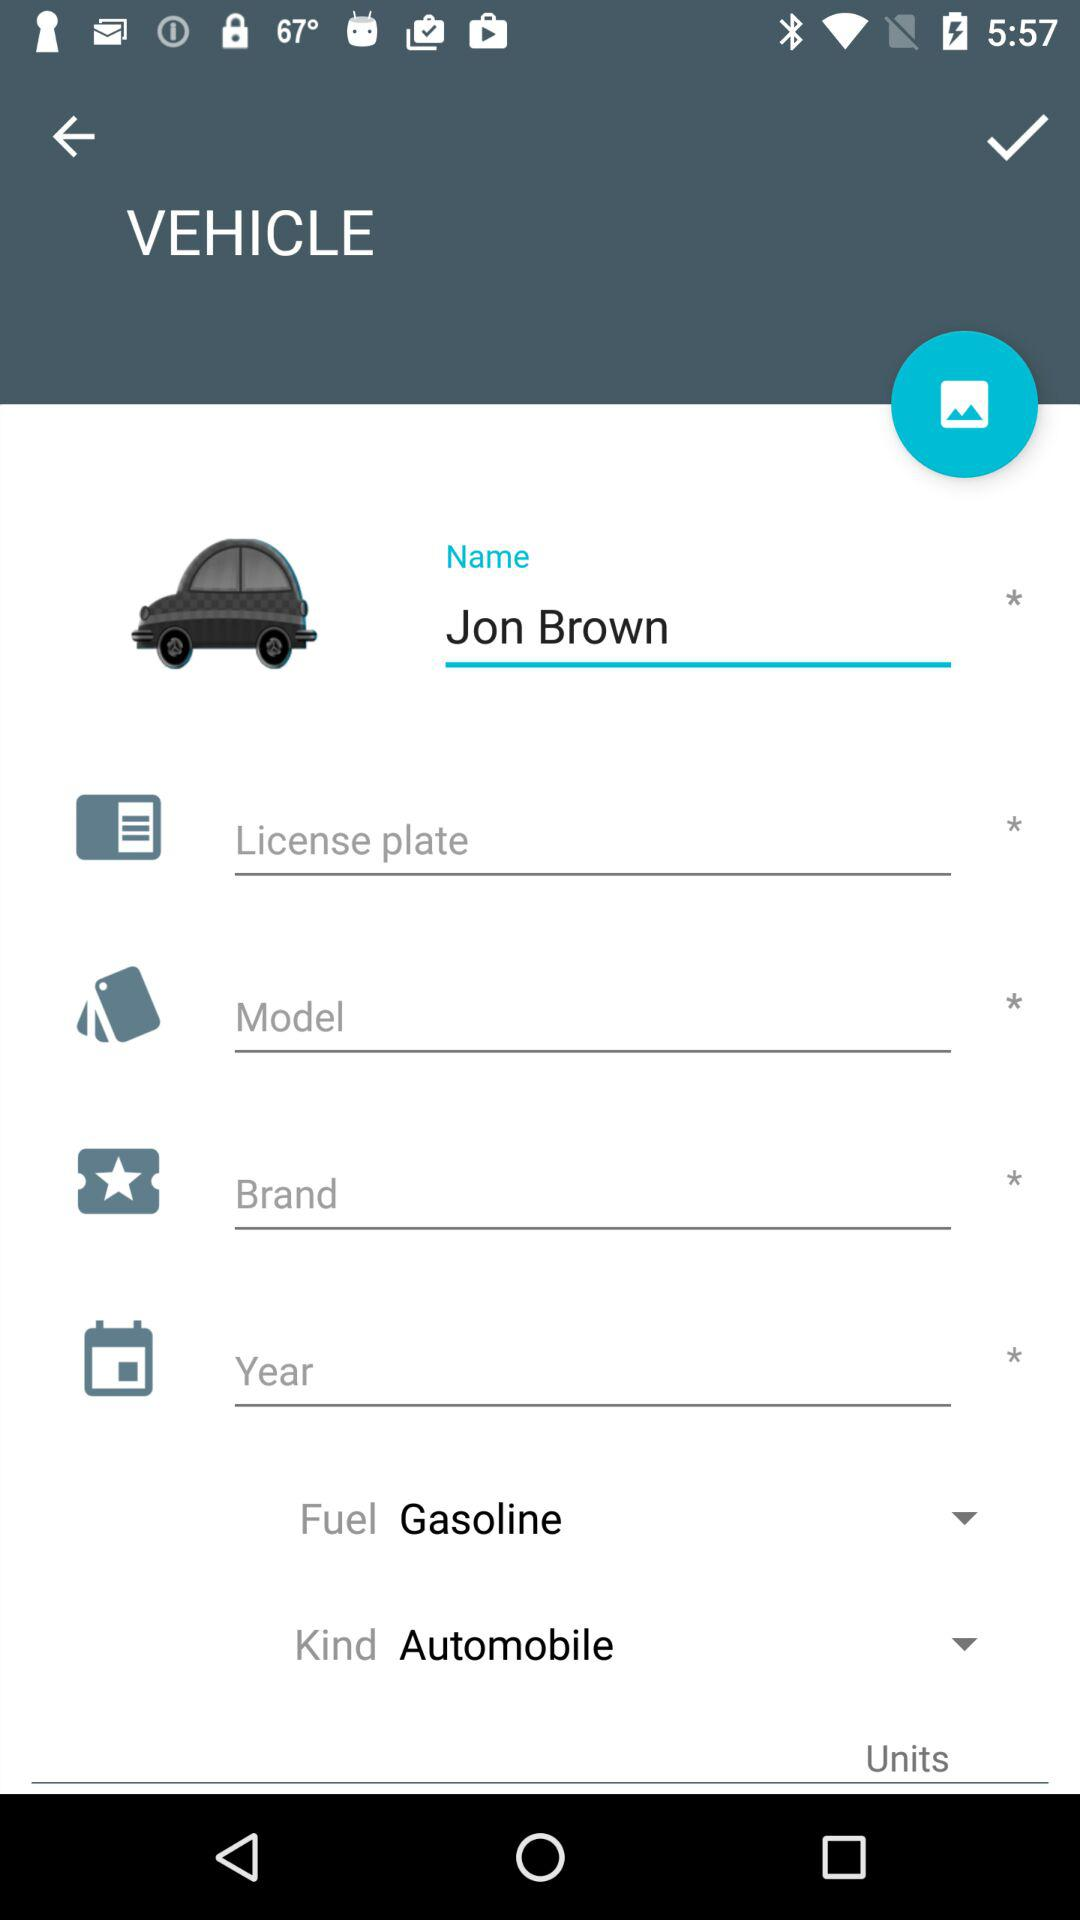What kind of vehicle is it? The vehicle is of the "Automobile" kind. 